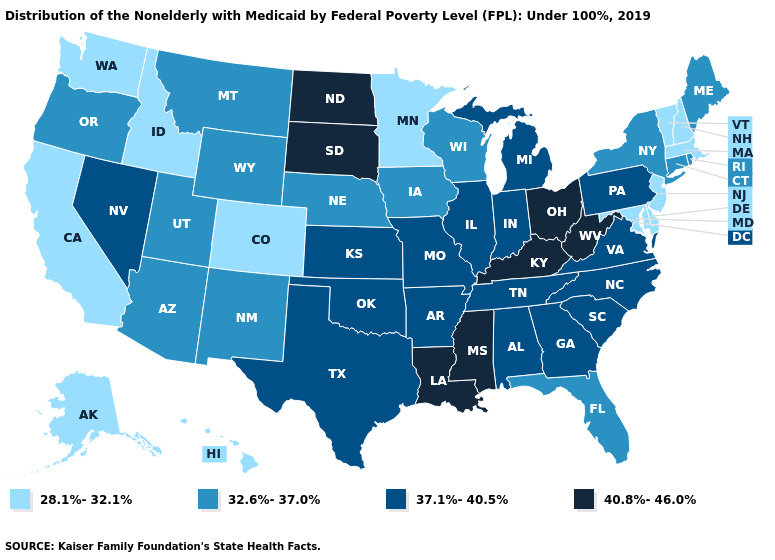Name the states that have a value in the range 37.1%-40.5%?
Answer briefly. Alabama, Arkansas, Georgia, Illinois, Indiana, Kansas, Michigan, Missouri, Nevada, North Carolina, Oklahoma, Pennsylvania, South Carolina, Tennessee, Texas, Virginia. Name the states that have a value in the range 32.6%-37.0%?
Keep it brief. Arizona, Connecticut, Florida, Iowa, Maine, Montana, Nebraska, New Mexico, New York, Oregon, Rhode Island, Utah, Wisconsin, Wyoming. Name the states that have a value in the range 40.8%-46.0%?
Short answer required. Kentucky, Louisiana, Mississippi, North Dakota, Ohio, South Dakota, West Virginia. Does the first symbol in the legend represent the smallest category?
Give a very brief answer. Yes. What is the value of Oklahoma?
Keep it brief. 37.1%-40.5%. Name the states that have a value in the range 37.1%-40.5%?
Be succinct. Alabama, Arkansas, Georgia, Illinois, Indiana, Kansas, Michigan, Missouri, Nevada, North Carolina, Oklahoma, Pennsylvania, South Carolina, Tennessee, Texas, Virginia. What is the highest value in the USA?
Concise answer only. 40.8%-46.0%. What is the lowest value in states that border Louisiana?
Quick response, please. 37.1%-40.5%. Name the states that have a value in the range 28.1%-32.1%?
Write a very short answer. Alaska, California, Colorado, Delaware, Hawaii, Idaho, Maryland, Massachusetts, Minnesota, New Hampshire, New Jersey, Vermont, Washington. Name the states that have a value in the range 32.6%-37.0%?
Write a very short answer. Arizona, Connecticut, Florida, Iowa, Maine, Montana, Nebraska, New Mexico, New York, Oregon, Rhode Island, Utah, Wisconsin, Wyoming. Which states have the highest value in the USA?
Write a very short answer. Kentucky, Louisiana, Mississippi, North Dakota, Ohio, South Dakota, West Virginia. Name the states that have a value in the range 32.6%-37.0%?
Give a very brief answer. Arizona, Connecticut, Florida, Iowa, Maine, Montana, Nebraska, New Mexico, New York, Oregon, Rhode Island, Utah, Wisconsin, Wyoming. Among the states that border Wyoming , does Montana have the lowest value?
Quick response, please. No. Name the states that have a value in the range 40.8%-46.0%?
Be succinct. Kentucky, Louisiana, Mississippi, North Dakota, Ohio, South Dakota, West Virginia. 